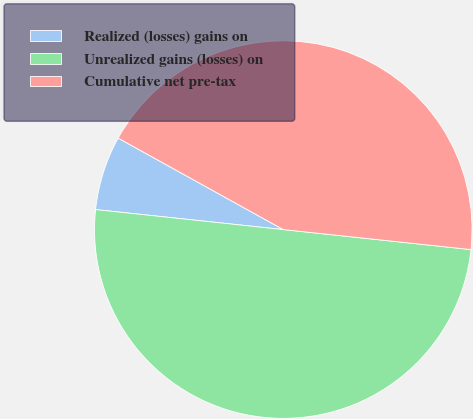<chart> <loc_0><loc_0><loc_500><loc_500><pie_chart><fcel>Realized (losses) gains on<fcel>Unrealized gains (losses) on<fcel>Cumulative net pre-tax<nl><fcel>6.36%<fcel>50.0%<fcel>43.64%<nl></chart> 